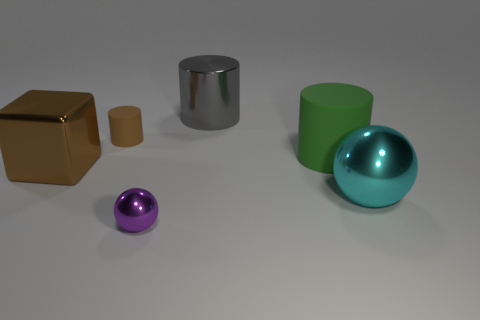There is a tiny cylinder that is the same color as the large block; what is its material?
Provide a short and direct response. Rubber. How many other objects are the same shape as the cyan metal thing?
Your answer should be compact. 1. What material is the small thing to the left of the tiny thing that is in front of the big cyan sphere?
Provide a succinct answer. Rubber. What number of metal things are big brown blocks or big green cylinders?
Your answer should be compact. 1. There is a metallic ball that is left of the cyan metallic ball; are there any big shiny things that are right of it?
Keep it short and to the point. Yes. How many things are large metallic cylinders to the right of the brown cube or tiny things to the left of the purple thing?
Offer a very short reply. 2. Are there any other things of the same color as the tiny shiny sphere?
Keep it short and to the point. No. What is the color of the shiny ball that is on the right side of the metal sphere that is in front of the cyan object that is behind the tiny ball?
Your answer should be compact. Cyan. How big is the metal ball in front of the big thing in front of the brown metal object?
Give a very brief answer. Small. There is a cylinder that is both right of the tiny cylinder and in front of the metal cylinder; what material is it made of?
Your answer should be compact. Rubber. 